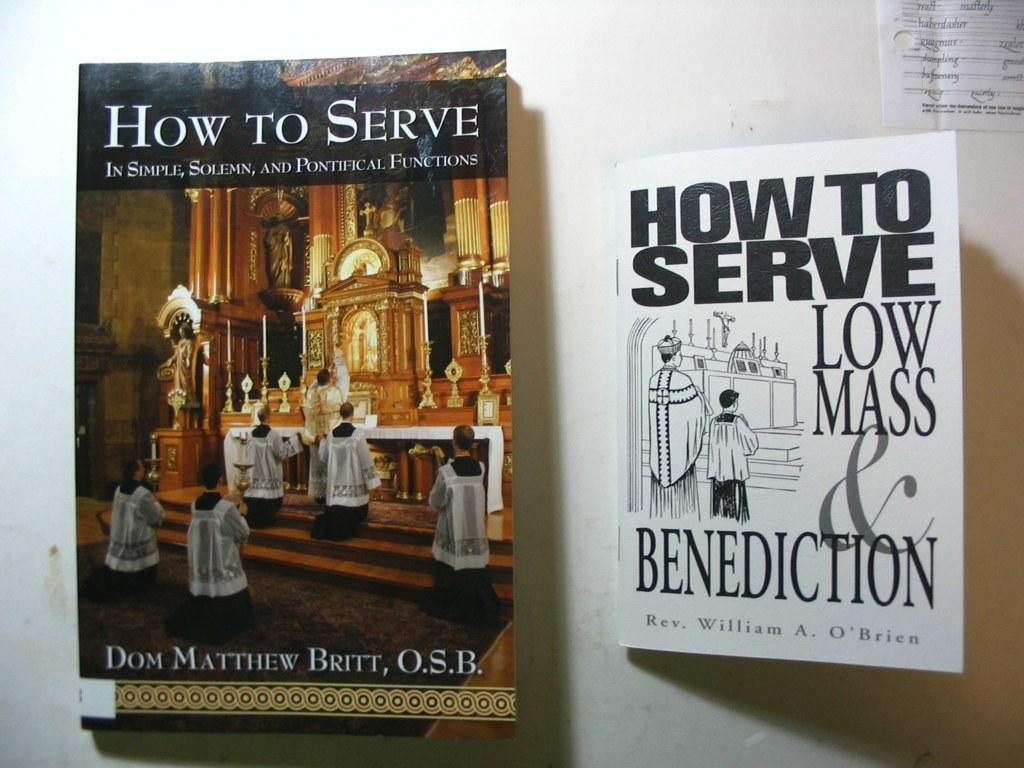<image>
Render a clear and concise summary of the photo. Two books on how to serve a Mass sit side by side. 